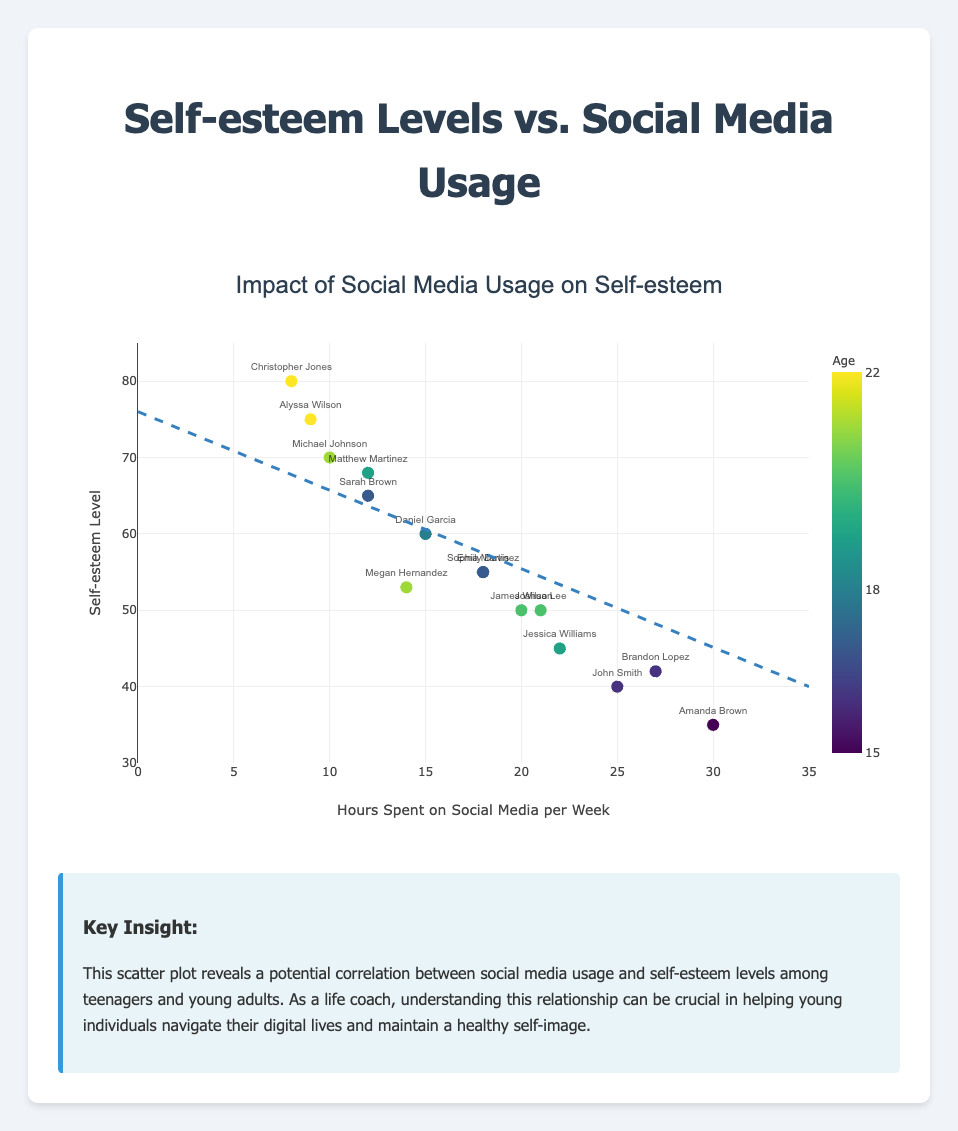What is the title of the scatter plot? The title can be found at the top of the scatter plot. It reads "Impact of Social Media Usage on Self-esteem."
Answer: Impact of Social Media Usage on Self-esteem How many data points are represented in the scatter plot? By counting the individual points on the scatter plot, we can see that there are 15 data points.
Answer: 15 What is the x-axis labeled? The x-axis label is indicated at the bottom of the plot and it reads "Hours Spent on Social Media per Week."
Answer: Hours Spent on Social Media per Week What is the y-axis labeled? The y-axis label is indicated on the left side of the plot and it reads "Self-esteem Level."
Answer: Self-esteem Level What does the trend line indicate about the relationship between social media usage and self-esteem? The trend line slopes downwards from left to right, suggesting that as the number of hours spent on social media per week increases, the self-esteem levels tend to decrease.
Answer: Negative correlation Which individual has the highest self-esteem level and how many hours do they spend on social media per week? According to the data points and names displayed on the plot, Christopher Jones has the highest self-esteem level of 80 and spends 8 hours on social media per week.
Answer: Christopher Jones, 8 hours Who spends the most hours on social media per week and what is their self-esteem level? Among the data points, Amanda Brown spends the most time on social media, which is 30 hours per week, and her self-esteem level is 35.
Answer: Amanda Brown, 35 Compare the self-esteem levels of Michael Johnson and Brandon Lopez. Who has a higher self-esteem level and by how much? Michael Johnson's self-esteem level is 70, while Brandon Lopez's is 42. The difference is 70 - 42 = 28.
Answer: Michael Johnson, 28 What is the general trend in self-esteem levels for individuals aged 20 and above? Observing the color and age indicated on the color scale, individuals aged 20 and above (James Wilson, Megan Hernandez, Alyssa Wilson, and Joshua Lee) have self-esteem levels varying from 50 to 75, indicating no strong age-specific trend within that group.
Answer: Varied self-esteem levels Which age group has the most consistent self-esteem levels, considering their respective social media usage? By analyzing the x and y coordinates for each age group, the 17-year-olds (Sarah Brown and Sophia Martinez) have similar self-esteem levels of 65 and 55 and have similar social media usage of 12 and 18 hours per week, suggesting consistency.
Answer: 17-year-olds 